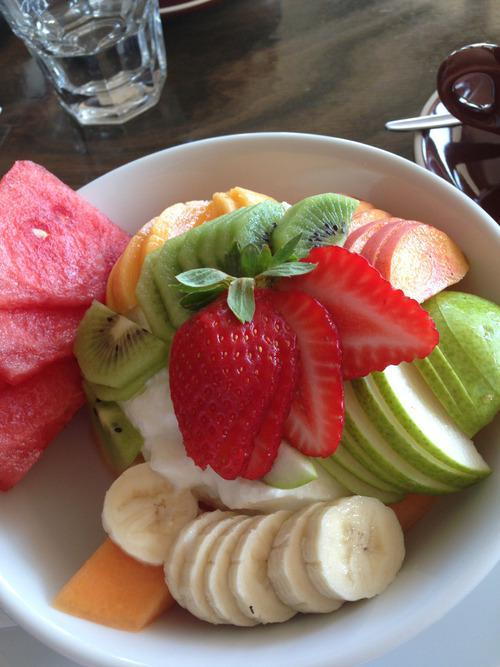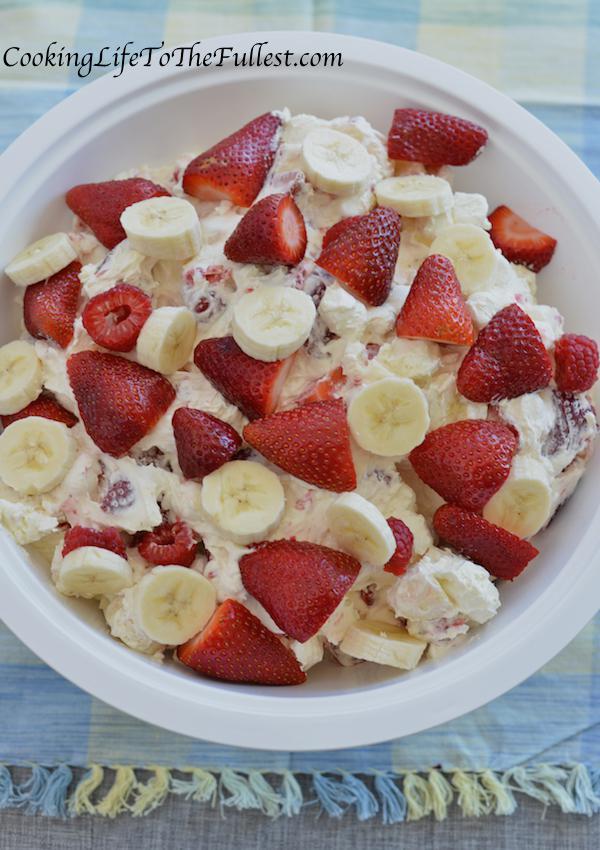The first image is the image on the left, the second image is the image on the right. Analyze the images presented: Is the assertion "An image shows a bowl topped with strawberry and a green leafy spring." valid? Answer yes or no. Yes. 